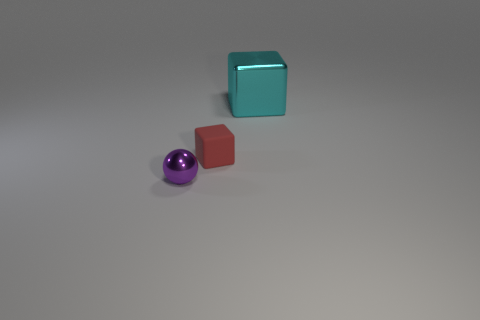Add 2 small metal spheres. How many objects exist? 5 Subtract all blocks. How many objects are left? 1 Subtract all big green objects. Subtract all cyan metallic cubes. How many objects are left? 2 Add 1 small red things. How many small red things are left? 2 Add 2 large cyan things. How many large cyan things exist? 3 Subtract 0 blue cylinders. How many objects are left? 3 